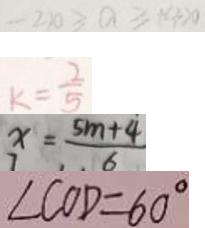Convert formula to latex. <formula><loc_0><loc_0><loc_500><loc_500>- 2 2 0 > a \geq 1 4 > 0 
 k = \frac { 2 } { 5 } 
 x = \frac { 5 m + 4 } { 6 } 
 \angle C O D = 6 0 ^ { \circ }</formula> 